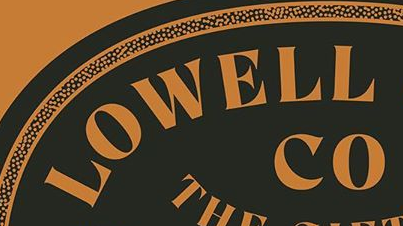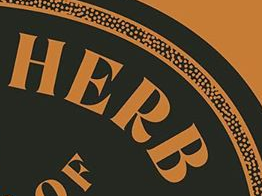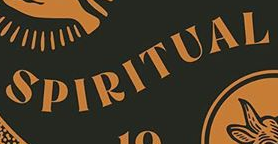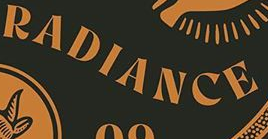Read the text from these images in sequence, separated by a semicolon. LOWELL; HERB; SPIRITUAL; RADIANCE 